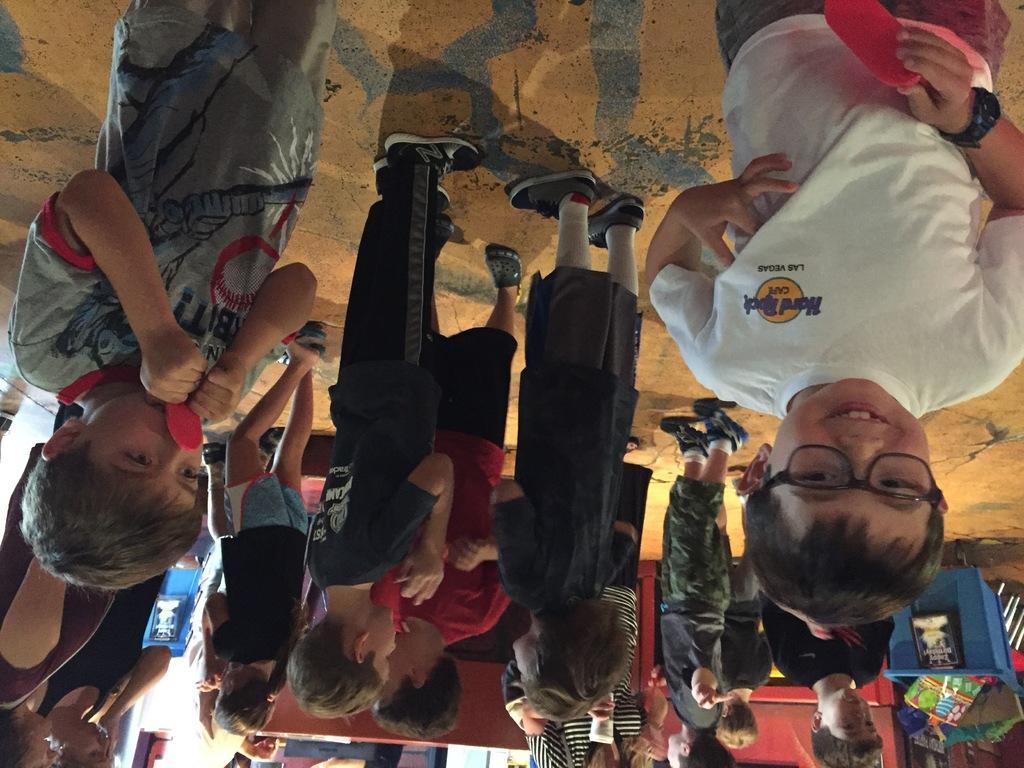How would you summarize this image in a sentence or two? In this image I can see there are few persons standing at the bottom right I can see a basket. 